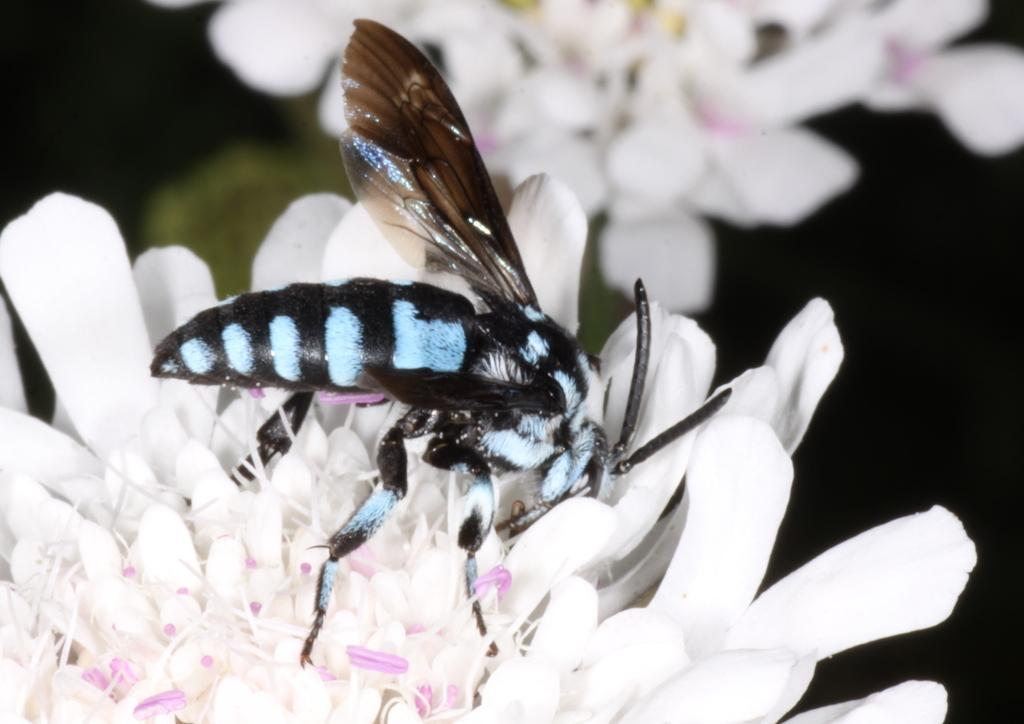What is present on the flower in the image? There is an insect on the flower in the image. Can you describe the insect's location on the flower? The insect is on the flower in the image. What type of twig is the insect using to practice its religion in the image? There is no twig or religious practice depicted in the image; it features an insect on a flower. Who is the representative of the insect in the image? There is no representative present in the image; it simply shows an insect on a flower. 